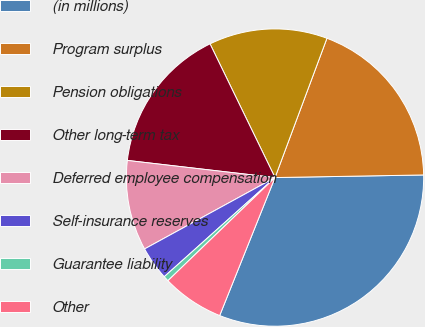Convert chart. <chart><loc_0><loc_0><loc_500><loc_500><pie_chart><fcel>(in millions)<fcel>Program surplus<fcel>Pension obligations<fcel>Other long-term tax<fcel>Deferred employee compensation<fcel>Self-insurance reserves<fcel>Guarantee liability<fcel>Other<nl><fcel>31.35%<fcel>19.04%<fcel>12.88%<fcel>15.96%<fcel>9.81%<fcel>3.65%<fcel>0.58%<fcel>6.73%<nl></chart> 